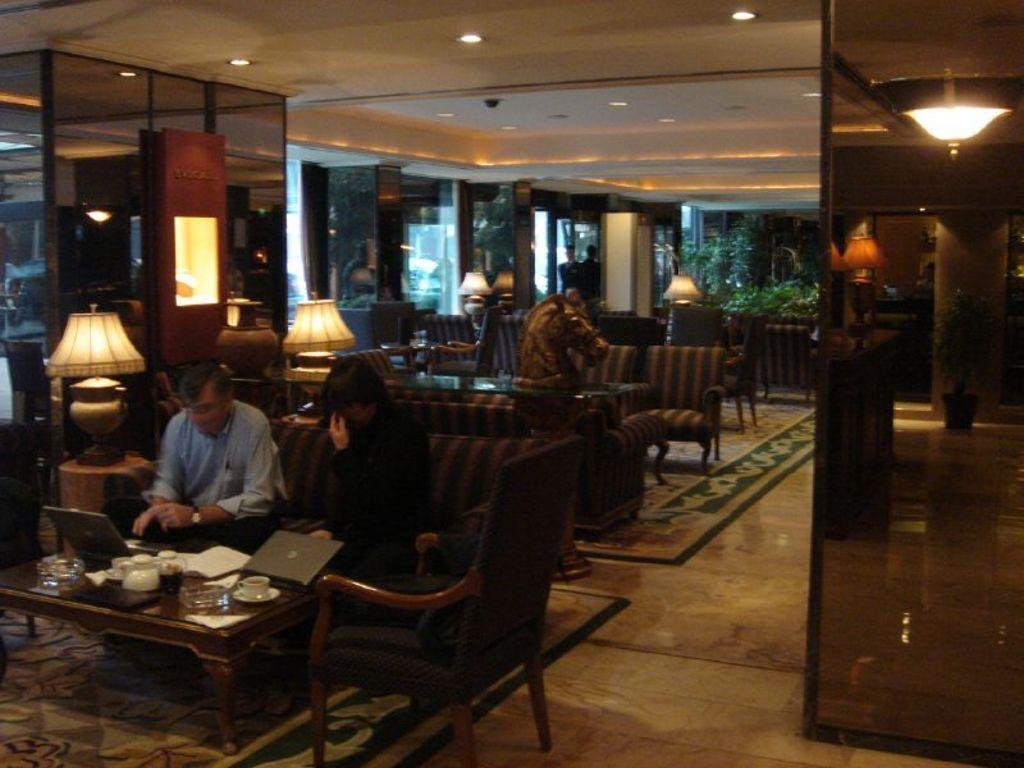Could you give a brief overview of what you see in this image? In this image I can see two people sitting on the couch. These people are wearing the different color dresses. In-front of these people I can see the glasses, cups, teapots and the laptops. To the side of these people I can see the lamps. In the background I can see the statue of an animal, tables and chairs. In the background I can see few more lamps, person and the plants. There are lights in the top. 